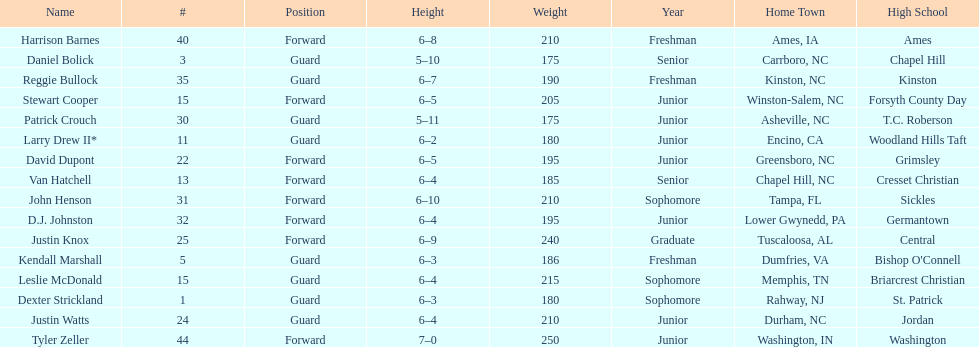Who was taller, justin knox or john henson? John Henson. 